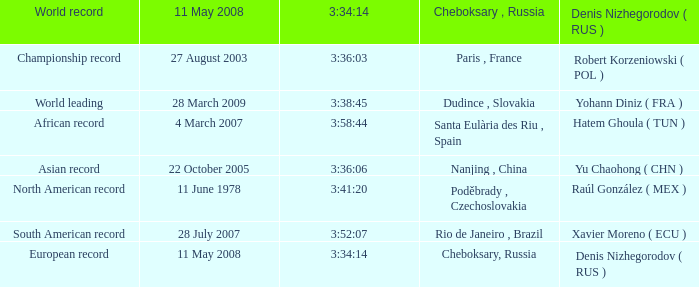When 3:41:20 is  3:34:14 what is cheboksary , russia? Poděbrady , Czechoslovakia. 